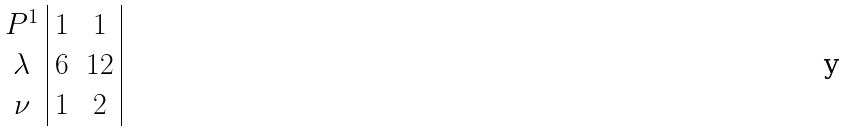Convert formula to latex. <formula><loc_0><loc_0><loc_500><loc_500>\begin{array} { c | c c | } { P } ^ { 1 } & 1 & 1 \\ \lambda & 6 & 1 2 \\ \nu & 1 & 2 \end{array}</formula> 